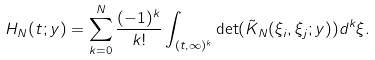Convert formula to latex. <formula><loc_0><loc_0><loc_500><loc_500>H _ { N } ( t ; y ) = \sum _ { k = 0 } ^ { N } \frac { ( - 1 ) ^ { k } } { k ! } \int _ { ( t , \infty ) ^ { k } } \det ( \tilde { K } _ { N } ( \xi _ { i } , \xi _ { j } ; y ) ) d ^ { k } \xi .</formula> 